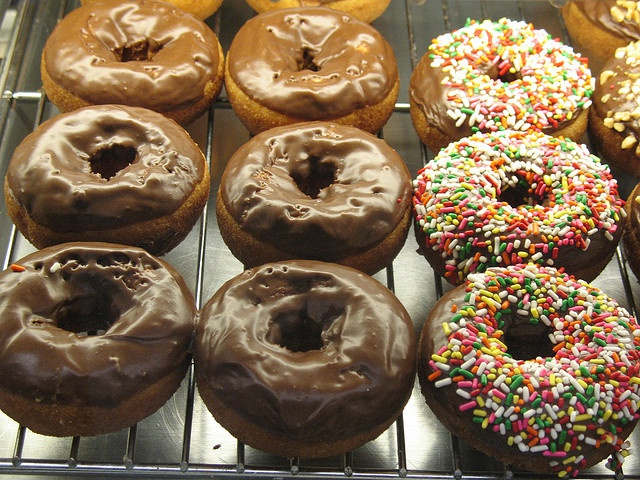Describe the objects in this image and their specific colors. I can see donut in gray, black, maroon, beige, and darkgray tones, donut in gray, black, maroon, and tan tones, donut in gray, black, and maroon tones, donut in gray, ivory, black, khaki, and maroon tones, and donut in gray, black, maroon, and tan tones in this image. 